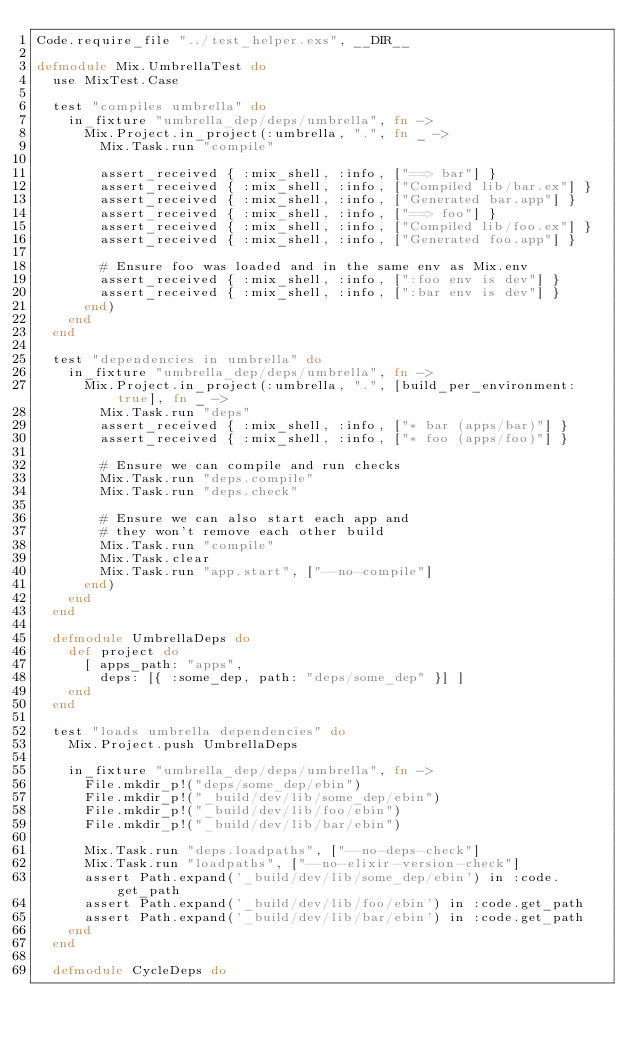<code> <loc_0><loc_0><loc_500><loc_500><_Elixir_>Code.require_file "../test_helper.exs", __DIR__

defmodule Mix.UmbrellaTest do
  use MixTest.Case

  test "compiles umbrella" do
    in_fixture "umbrella_dep/deps/umbrella", fn ->
      Mix.Project.in_project(:umbrella, ".", fn _ ->
        Mix.Task.run "compile"

        assert_received { :mix_shell, :info, ["==> bar"] }
        assert_received { :mix_shell, :info, ["Compiled lib/bar.ex"] }
        assert_received { :mix_shell, :info, ["Generated bar.app"] }
        assert_received { :mix_shell, :info, ["==> foo"] }
        assert_received { :mix_shell, :info, ["Compiled lib/foo.ex"] }
        assert_received { :mix_shell, :info, ["Generated foo.app"] }

        # Ensure foo was loaded and in the same env as Mix.env
        assert_received { :mix_shell, :info, [":foo env is dev"] }
        assert_received { :mix_shell, :info, [":bar env is dev"] }
      end)
    end
  end

  test "dependencies in umbrella" do
    in_fixture "umbrella_dep/deps/umbrella", fn ->
      Mix.Project.in_project(:umbrella, ".", [build_per_environment: true], fn _ ->
        Mix.Task.run "deps"
        assert_received { :mix_shell, :info, ["* bar (apps/bar)"] }
        assert_received { :mix_shell, :info, ["* foo (apps/foo)"] }

        # Ensure we can compile and run checks
        Mix.Task.run "deps.compile"
        Mix.Task.run "deps.check"

        # Ensure we can also start each app and
        # they won't remove each other build
        Mix.Task.run "compile"
        Mix.Task.clear
        Mix.Task.run "app.start", ["--no-compile"]
      end)
    end
  end

  defmodule UmbrellaDeps do
    def project do
      [ apps_path: "apps",
        deps: [{ :some_dep, path: "deps/some_dep" }] ]
    end
  end

  test "loads umbrella dependencies" do
    Mix.Project.push UmbrellaDeps

    in_fixture "umbrella_dep/deps/umbrella", fn ->
      File.mkdir_p!("deps/some_dep/ebin")
      File.mkdir_p!("_build/dev/lib/some_dep/ebin")
      File.mkdir_p!("_build/dev/lib/foo/ebin")
      File.mkdir_p!("_build/dev/lib/bar/ebin")

      Mix.Task.run "deps.loadpaths", ["--no-deps-check"]
      Mix.Task.run "loadpaths", ["--no-elixir-version-check"]
      assert Path.expand('_build/dev/lib/some_dep/ebin') in :code.get_path
      assert Path.expand('_build/dev/lib/foo/ebin') in :code.get_path
      assert Path.expand('_build/dev/lib/bar/ebin') in :code.get_path
    end
  end

  defmodule CycleDeps do</code> 